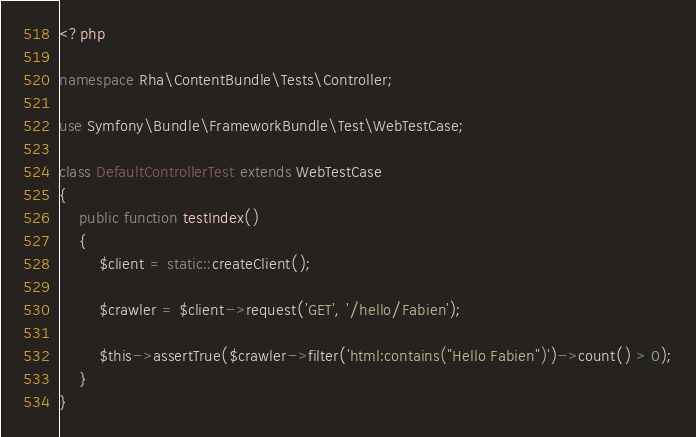<code> <loc_0><loc_0><loc_500><loc_500><_PHP_><?php

namespace Rha\ContentBundle\Tests\Controller;

use Symfony\Bundle\FrameworkBundle\Test\WebTestCase;

class DefaultControllerTest extends WebTestCase
{
    public function testIndex()
    {
        $client = static::createClient();

        $crawler = $client->request('GET', '/hello/Fabien');

        $this->assertTrue($crawler->filter('html:contains("Hello Fabien")')->count() > 0);
    }
}
</code> 